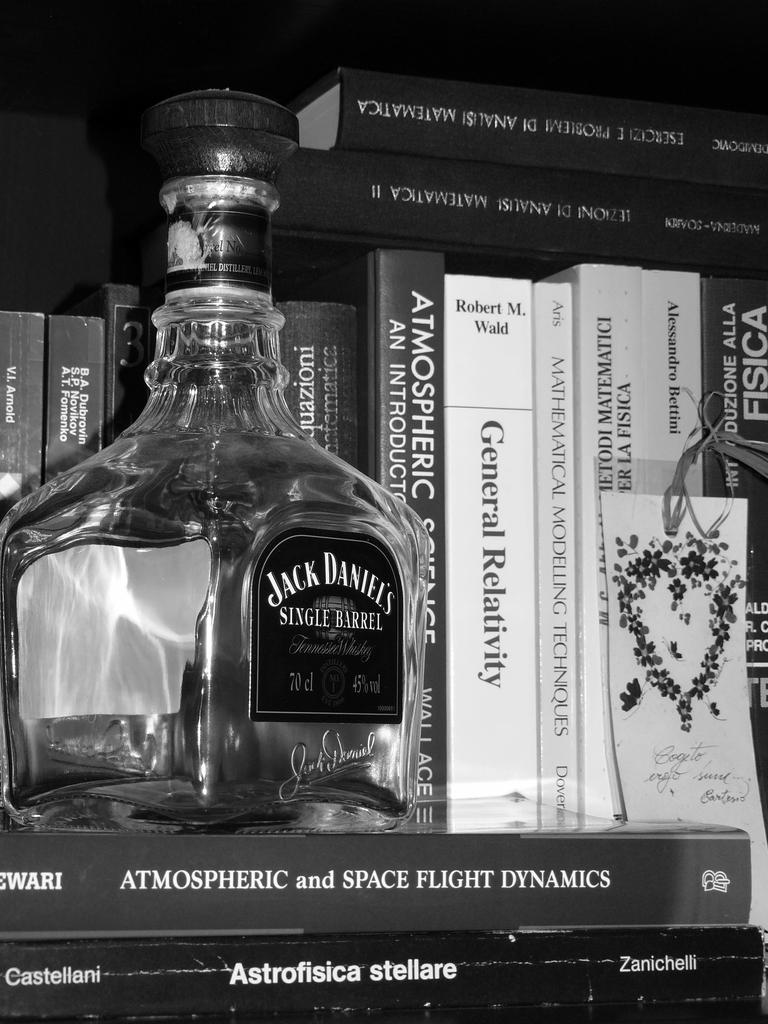Please provide a concise description of this image. A black and white picture. In-front of this books and above this books there is a bottle with sticker. 